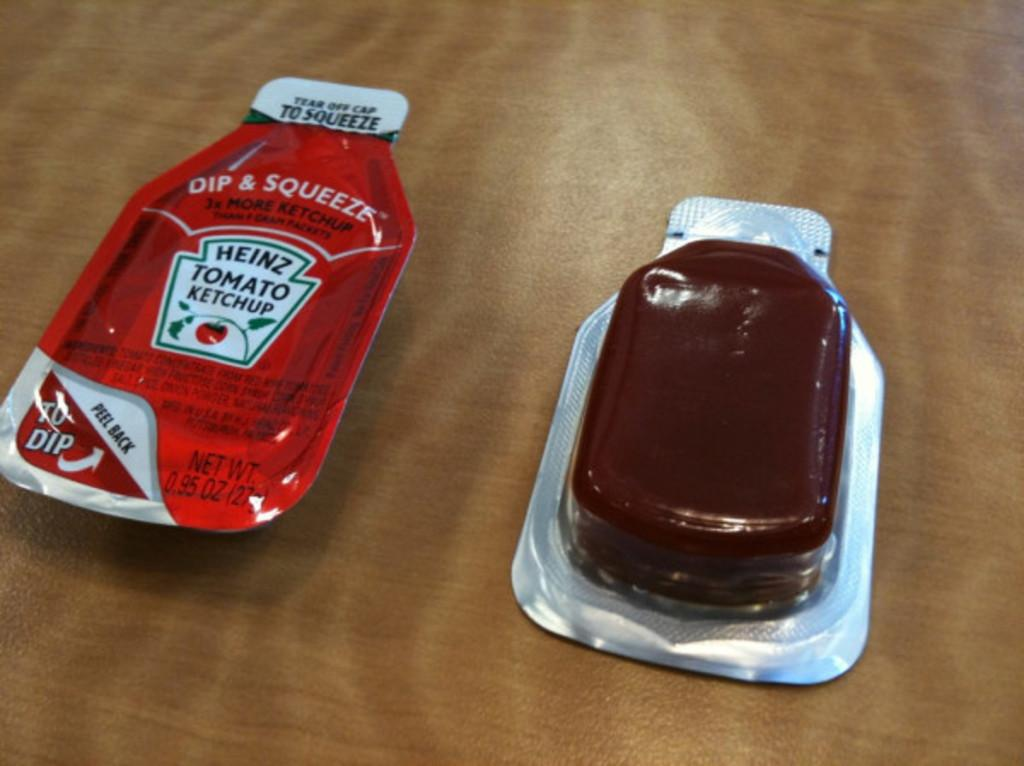Provide a one-sentence caption for the provided image. Two small packets of condiments, one is Heinz Ketchup and the other is flipped over and clear packaging so you can see the contents. 